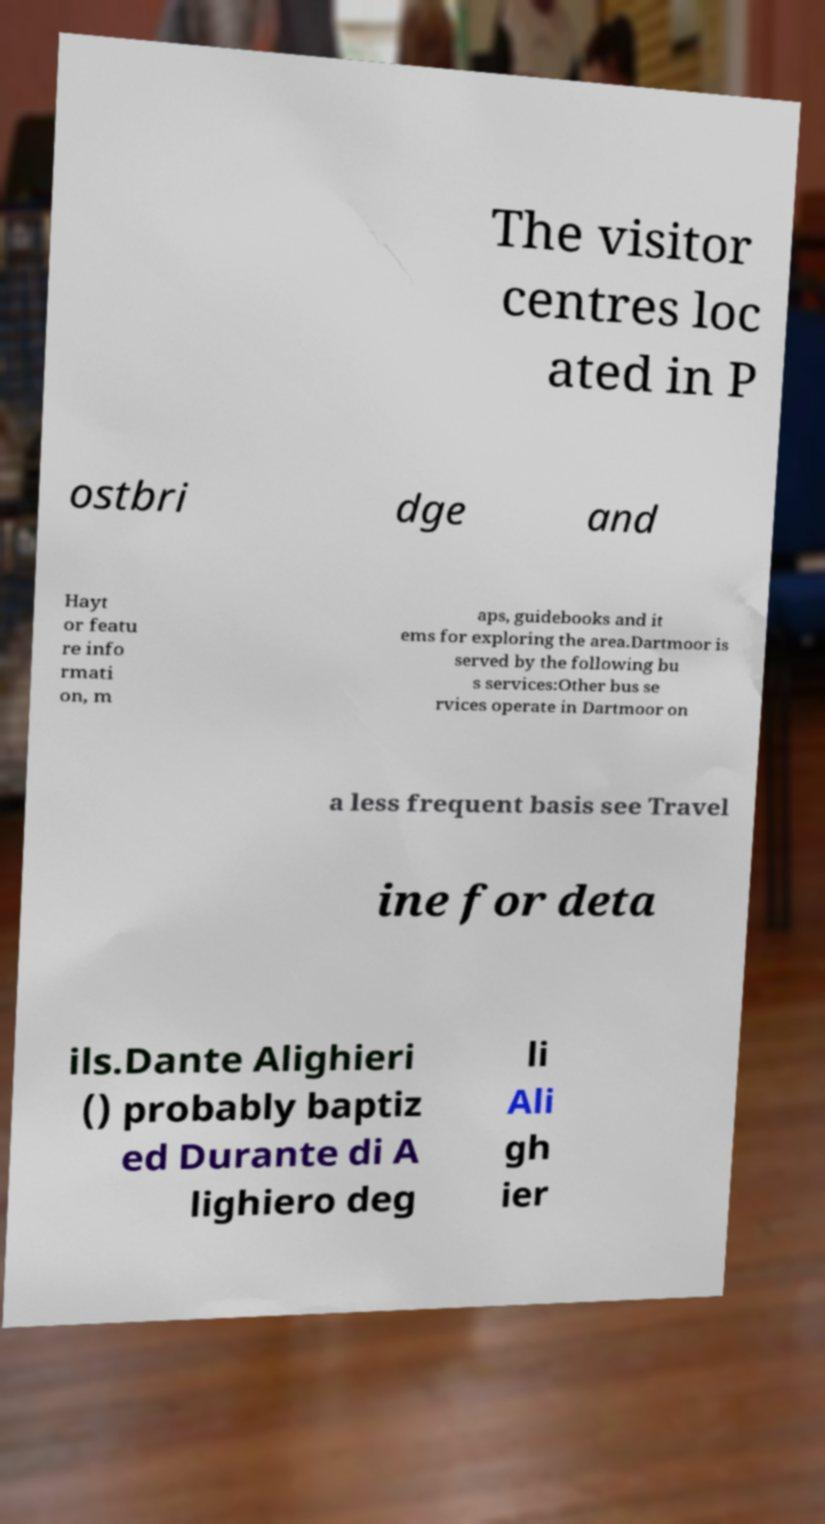Please identify and transcribe the text found in this image. The visitor centres loc ated in P ostbri dge and Hayt or featu re info rmati on, m aps, guidebooks and it ems for exploring the area.Dartmoor is served by the following bu s services:Other bus se rvices operate in Dartmoor on a less frequent basis see Travel ine for deta ils.Dante Alighieri () probably baptiz ed Durante di A lighiero deg li Ali gh ier 